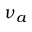Convert formula to latex. <formula><loc_0><loc_0><loc_500><loc_500>\nu _ { a }</formula> 